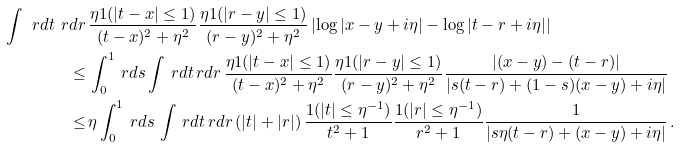Convert formula to latex. <formula><loc_0><loc_0><loc_500><loc_500>\int \ r d t \ r d r \, & \frac { \eta { 1 } ( | t - x | \leq 1 ) } { ( t - x ) ^ { 2 } + \eta ^ { 2 } } \frac { \eta { 1 } ( | r - y | \leq 1 ) } { ( r - y ) ^ { 2 } + \eta ^ { 2 } } \left | \log | x - y + i \eta | - \log | t - r + i \eta | \right | \\ \leq \, & \int _ { 0 } ^ { 1 } \ r d s \int \ r d t \ r d r \, \frac { \eta { 1 } ( | t - x | \leq 1 ) } { ( t - x ) ^ { 2 } + \eta ^ { 2 } } \frac { \eta { 1 } ( | r - y | \leq 1 ) } { ( r - y ) ^ { 2 } + \eta ^ { 2 } } \frac { | ( x - y ) - ( t - r ) | } { | s ( t - r ) + ( 1 - s ) ( x - y ) + i \eta | } \\ \leq \, & \eta \int _ { 0 } ^ { 1 } \ r d s \, \int \ r d t \ r d r \, ( | t | + | r | ) \, \frac { { 1 } ( | t | \leq \eta ^ { - 1 } ) } { t ^ { 2 } + 1 } \frac { { 1 } ( | r | \leq \eta ^ { - 1 } ) } { r ^ { 2 } + 1 } \frac { 1 } { | s \eta ( t - r ) + ( x - y ) + i \eta | } \, .</formula> 